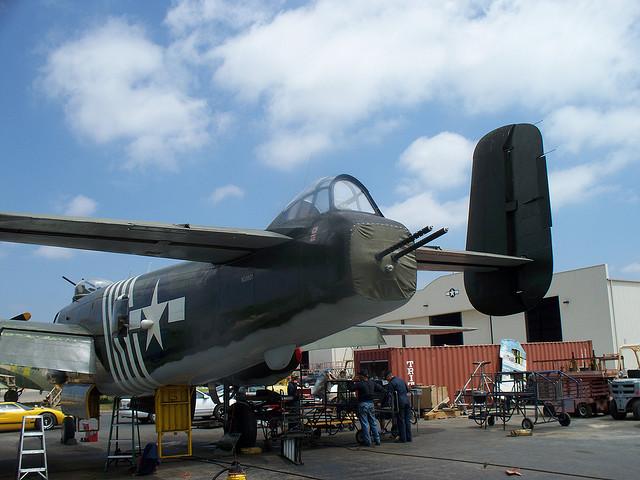Is the propeller of the plane missing?
Answer briefly. Yes. What's on the plane?
Answer briefly. Star. What is the function of the two rod-shaped objects on the back of the plane?
Write a very short answer. Balance. 